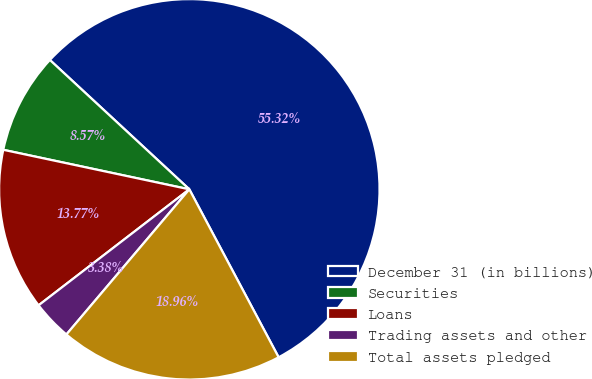Convert chart. <chart><loc_0><loc_0><loc_500><loc_500><pie_chart><fcel>December 31 (in billions)<fcel>Securities<fcel>Loans<fcel>Trading assets and other<fcel>Total assets pledged<nl><fcel>55.32%<fcel>8.57%<fcel>13.77%<fcel>3.38%<fcel>18.96%<nl></chart> 